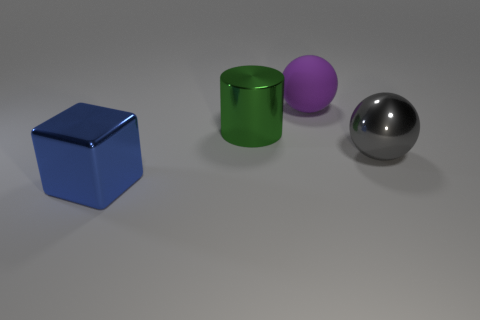Add 3 cubes. How many objects exist? 7 Subtract 1 spheres. How many spheres are left? 1 Subtract all purple matte things. Subtract all green metal cylinders. How many objects are left? 2 Add 2 shiny balls. How many shiny balls are left? 3 Add 4 big metal balls. How many big metal balls exist? 5 Subtract 0 red spheres. How many objects are left? 4 Subtract all cubes. How many objects are left? 3 Subtract all cyan cubes. Subtract all yellow spheres. How many cubes are left? 1 Subtract all cyan blocks. How many yellow spheres are left? 0 